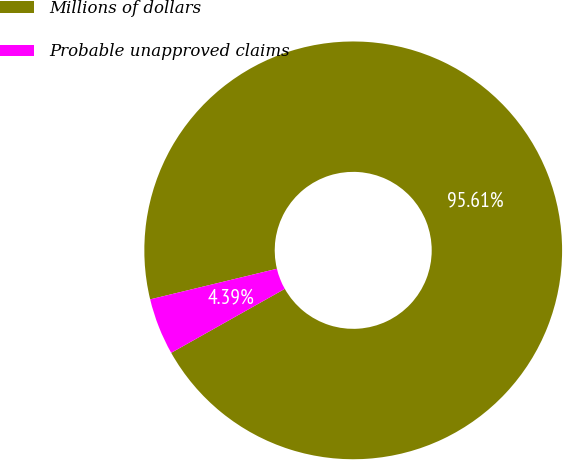<chart> <loc_0><loc_0><loc_500><loc_500><pie_chart><fcel>Millions of dollars<fcel>Probable unapproved claims<nl><fcel>95.61%<fcel>4.39%<nl></chart> 